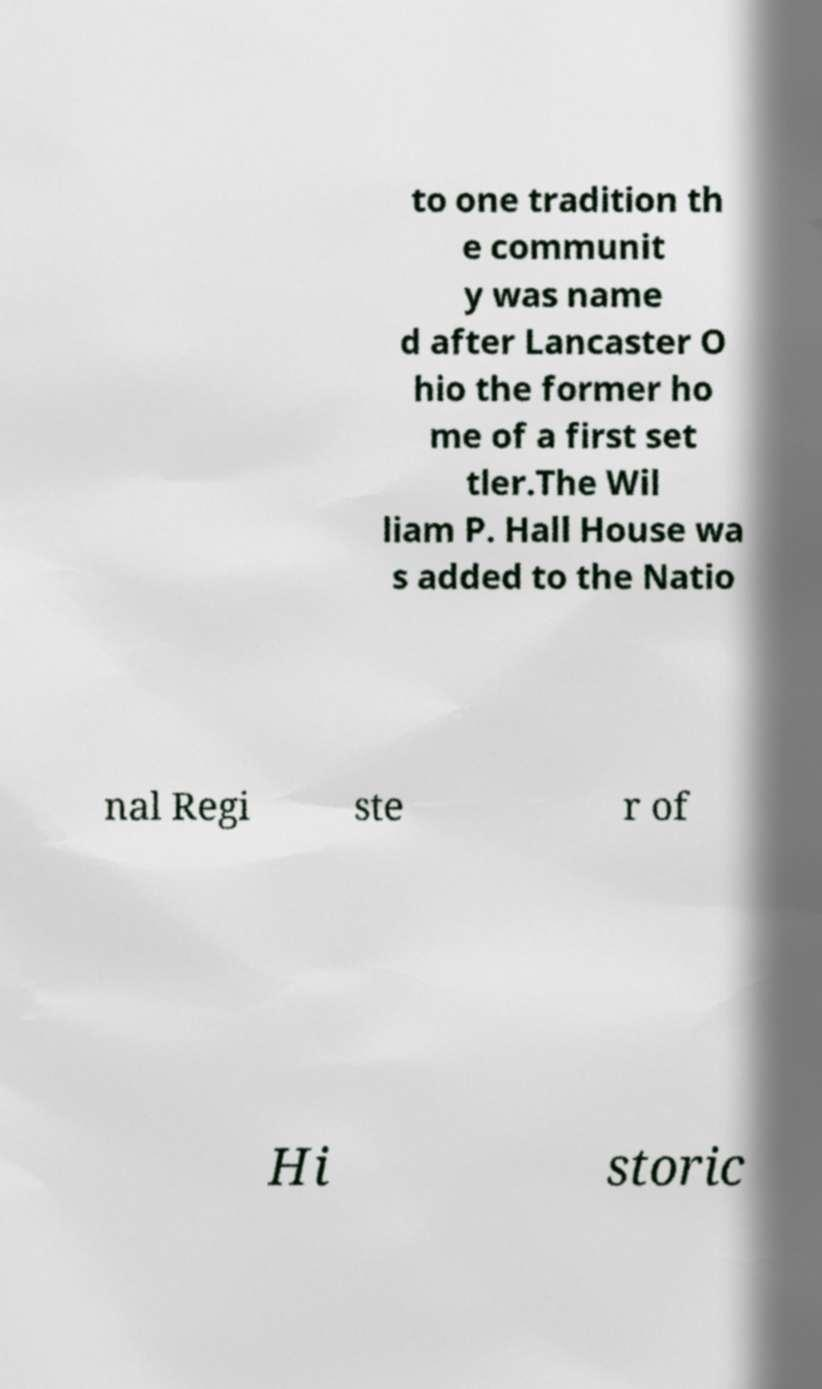There's text embedded in this image that I need extracted. Can you transcribe it verbatim? to one tradition th e communit y was name d after Lancaster O hio the former ho me of a first set tler.The Wil liam P. Hall House wa s added to the Natio nal Regi ste r of Hi storic 